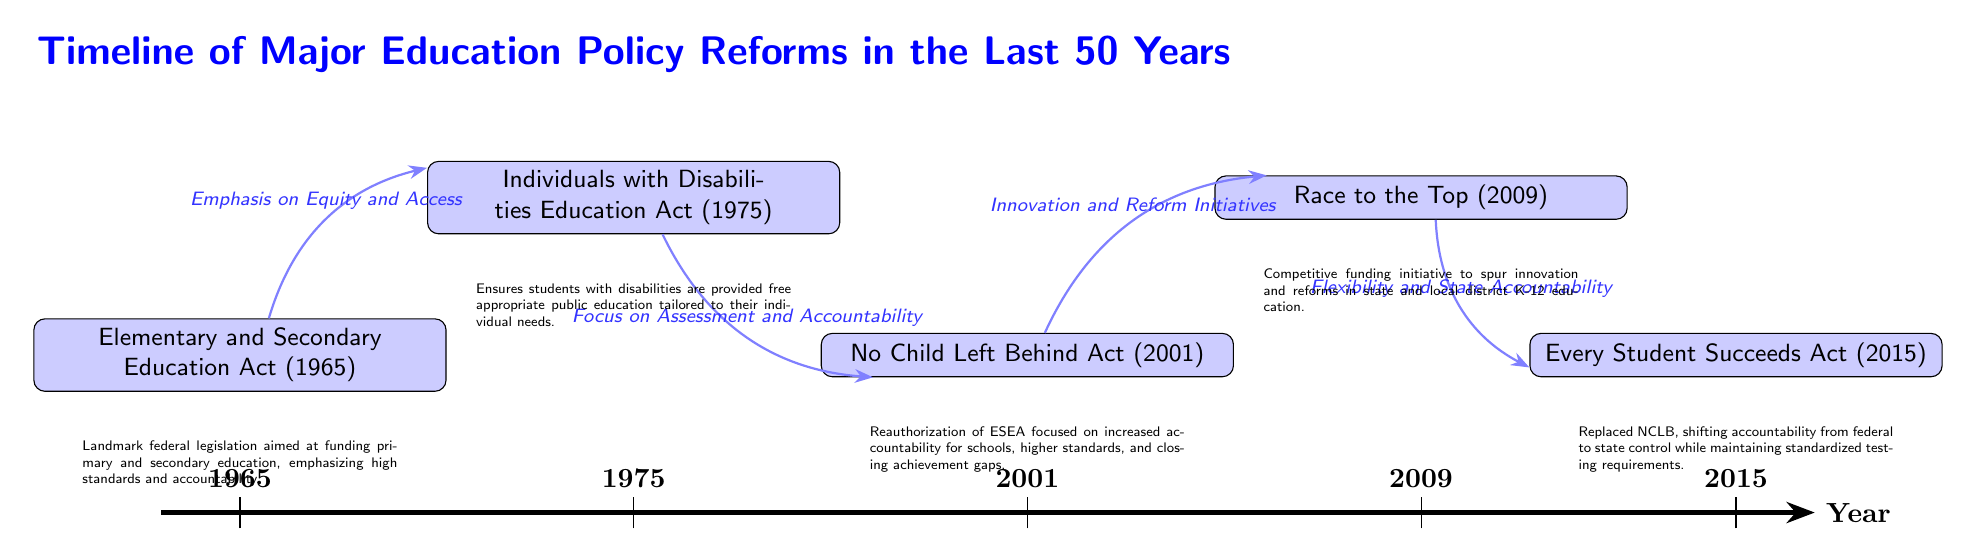What is the first event listed on the timeline? The first event (node) on the timeline is positioned at year 1965 and is labeled as the Elementary and Secondary Education Act.
Answer: Elementary and Secondary Education Act (1965) What year was the No Child Left Behind Act enacted? The No Child Left Behind Act is positioned on the timeline at the year 2001, which is indicated clearly above the event node.
Answer: 2001 How many events are shown in the diagram? By counting the event nodes displayed on the timeline, there are five distinct policy reform events shown: ESEA, IDEA, NCLB, RTT, and ESSA.
Answer: 5 Which event follows the Individuals with Disabilities Education Act on the timeline? The event that follows the Individuals with Disabilities Education Act, which is placed at 1975, is the No Child Left Behind Act, occurring in 2001.
Answer: No Child Left Behind Act (2001) What label describes the relationship between the No Child Left Behind Act and Race to the Top? The diagram clearly labels the relationship between these two events with “Innovation and Reform Initiatives,” indicating the focus on reforms linking the two policies.
Answer: Innovation and Reform Initiatives What was the focus of the Race to the Top initiative according to the diagram? The diagram specifies that the focus of the Race to the Top initiative is "Flexibility and State Accountability," detailing its push for state-level reforms and accountability measures.
Answer: Flexibility and State Accountability Which legislation was introduced as a replacement for the No Child Left Behind Act? The last event on the timeline is the Every Student Succeeds Act, which is indicated as a replacement for the preceding No Child Left Behind Act.
Answer: Every Student Succeeds Act (2015) What is the main emphasis of the Elementary and Secondary Education Act as described in the diagram? The description below the event node for the Elementary and Secondary Education Act states that it emphasizes "high standards and accountability," focusing on improving primary and secondary education.
Answer: high standards and accountability 